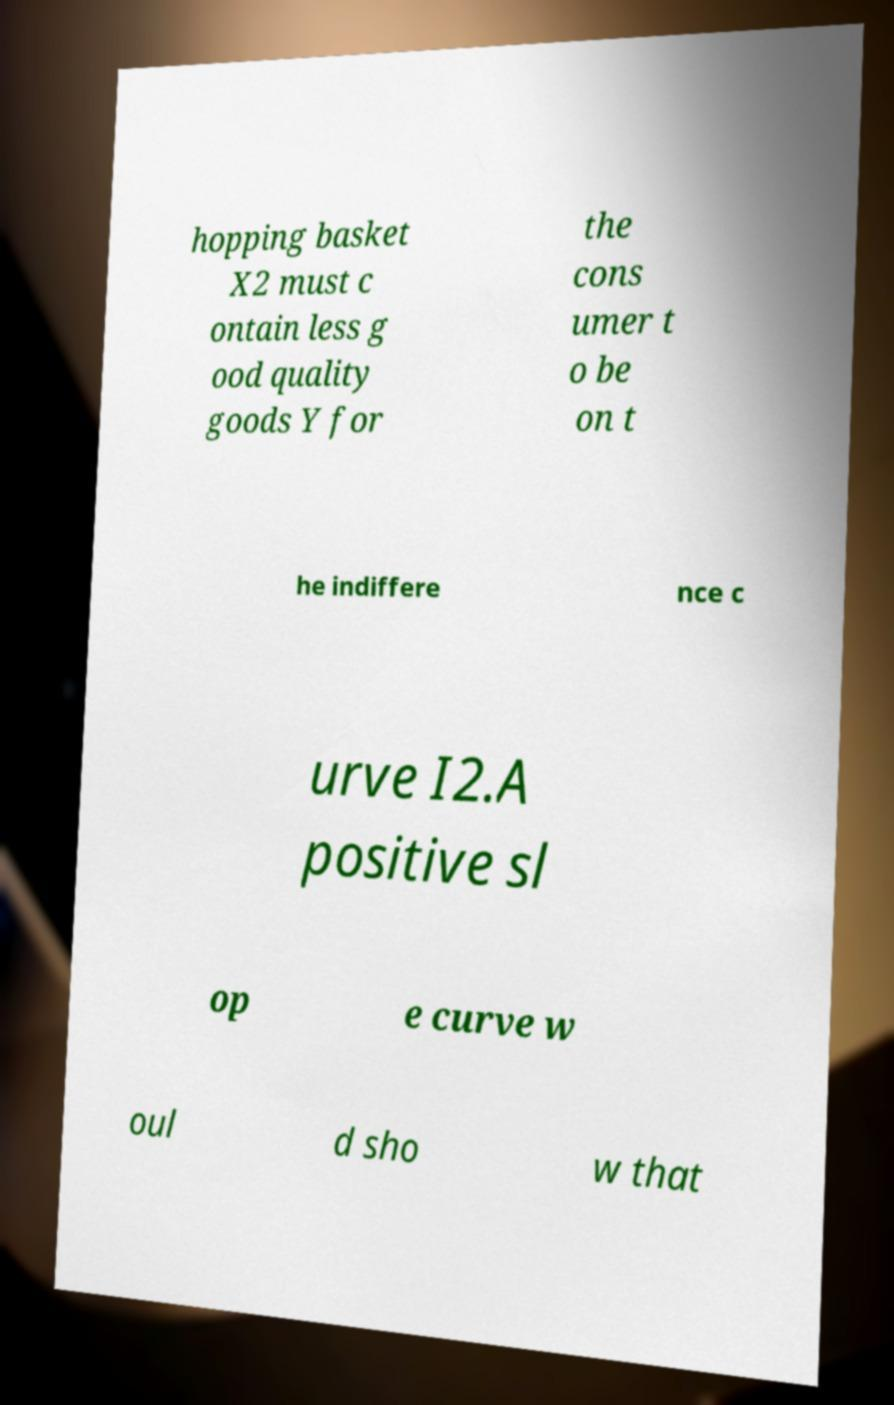What messages or text are displayed in this image? I need them in a readable, typed format. hopping basket X2 must c ontain less g ood quality goods Y for the cons umer t o be on t he indiffere nce c urve I2.A positive sl op e curve w oul d sho w that 